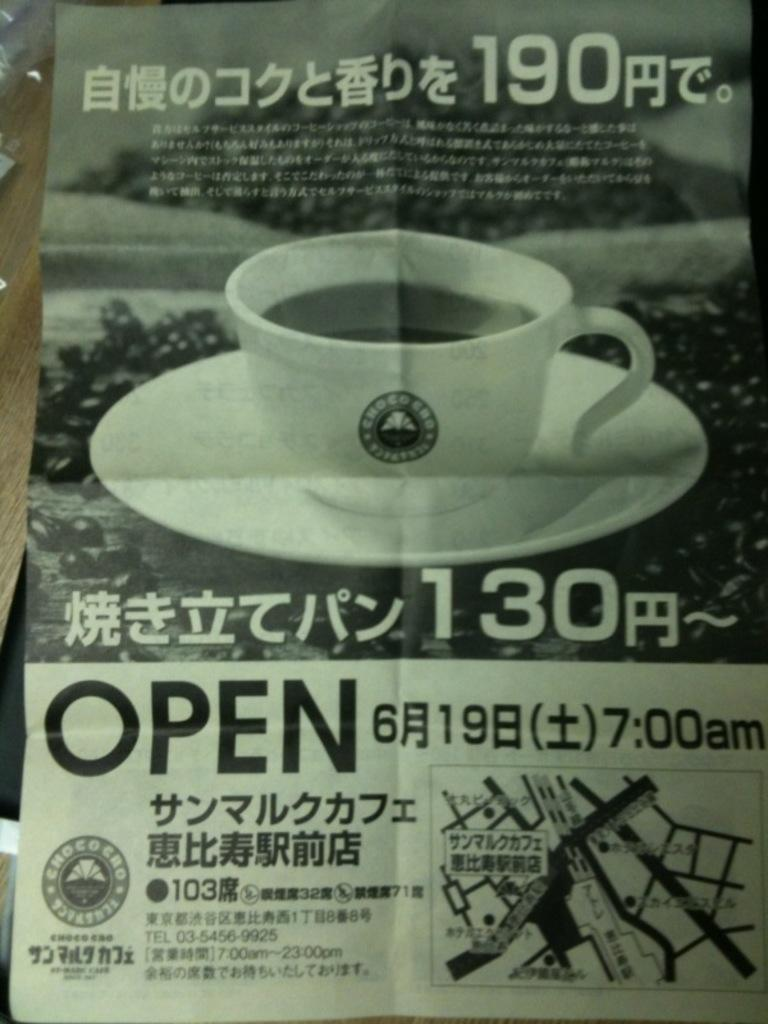What type of plate is in the image? There is a palm plate in the image. What can be found on the palm plate? There is text on the palm plate, as well as a cup and a saucer. How does the palm plate contribute to the harmony of the image? The palm plate itself does not contribute to the harmony of the image, as harmony is a subjective concept and not something that can be determined from the image alone. 